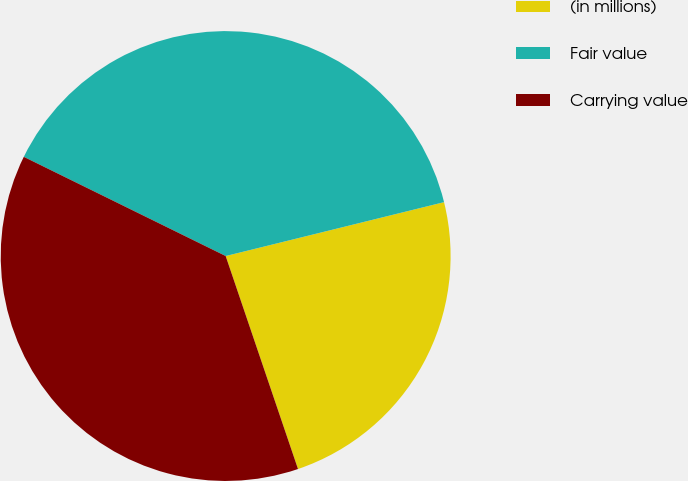Convert chart to OTSL. <chart><loc_0><loc_0><loc_500><loc_500><pie_chart><fcel>(in millions)<fcel>Fair value<fcel>Carrying value<nl><fcel>23.64%<fcel>38.88%<fcel>37.48%<nl></chart> 